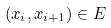<formula> <loc_0><loc_0><loc_500><loc_500>( x _ { i } , x _ { i + 1 } ) \in E</formula> 